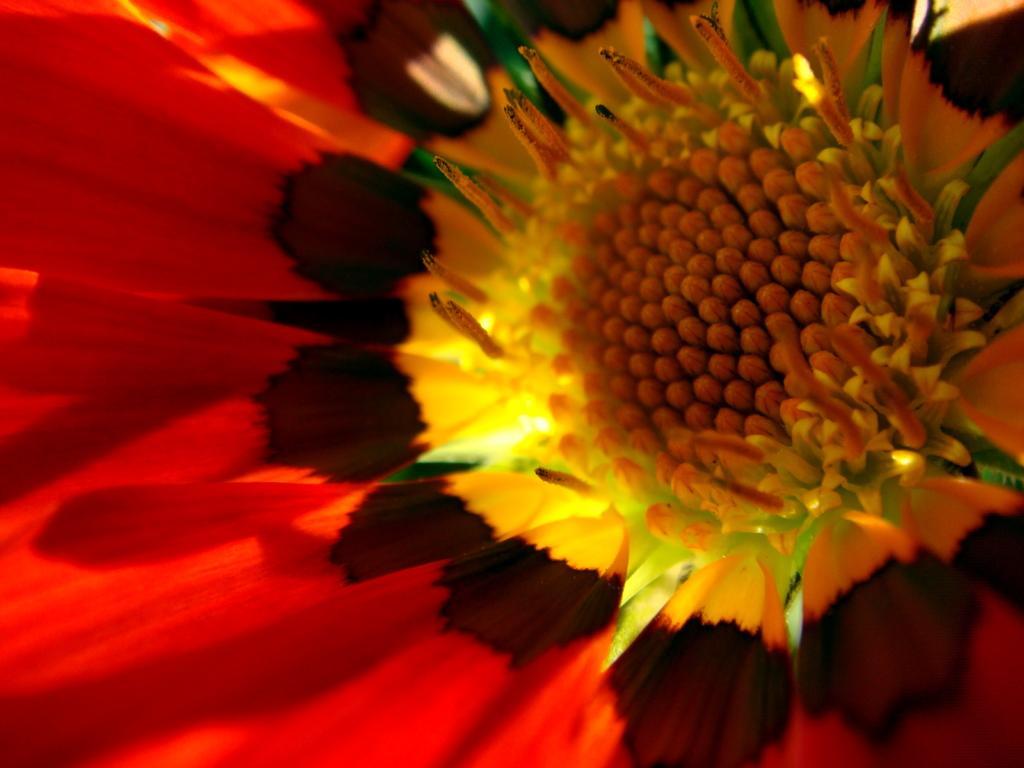Please provide a concise description of this image. In this image we can see a flower. 